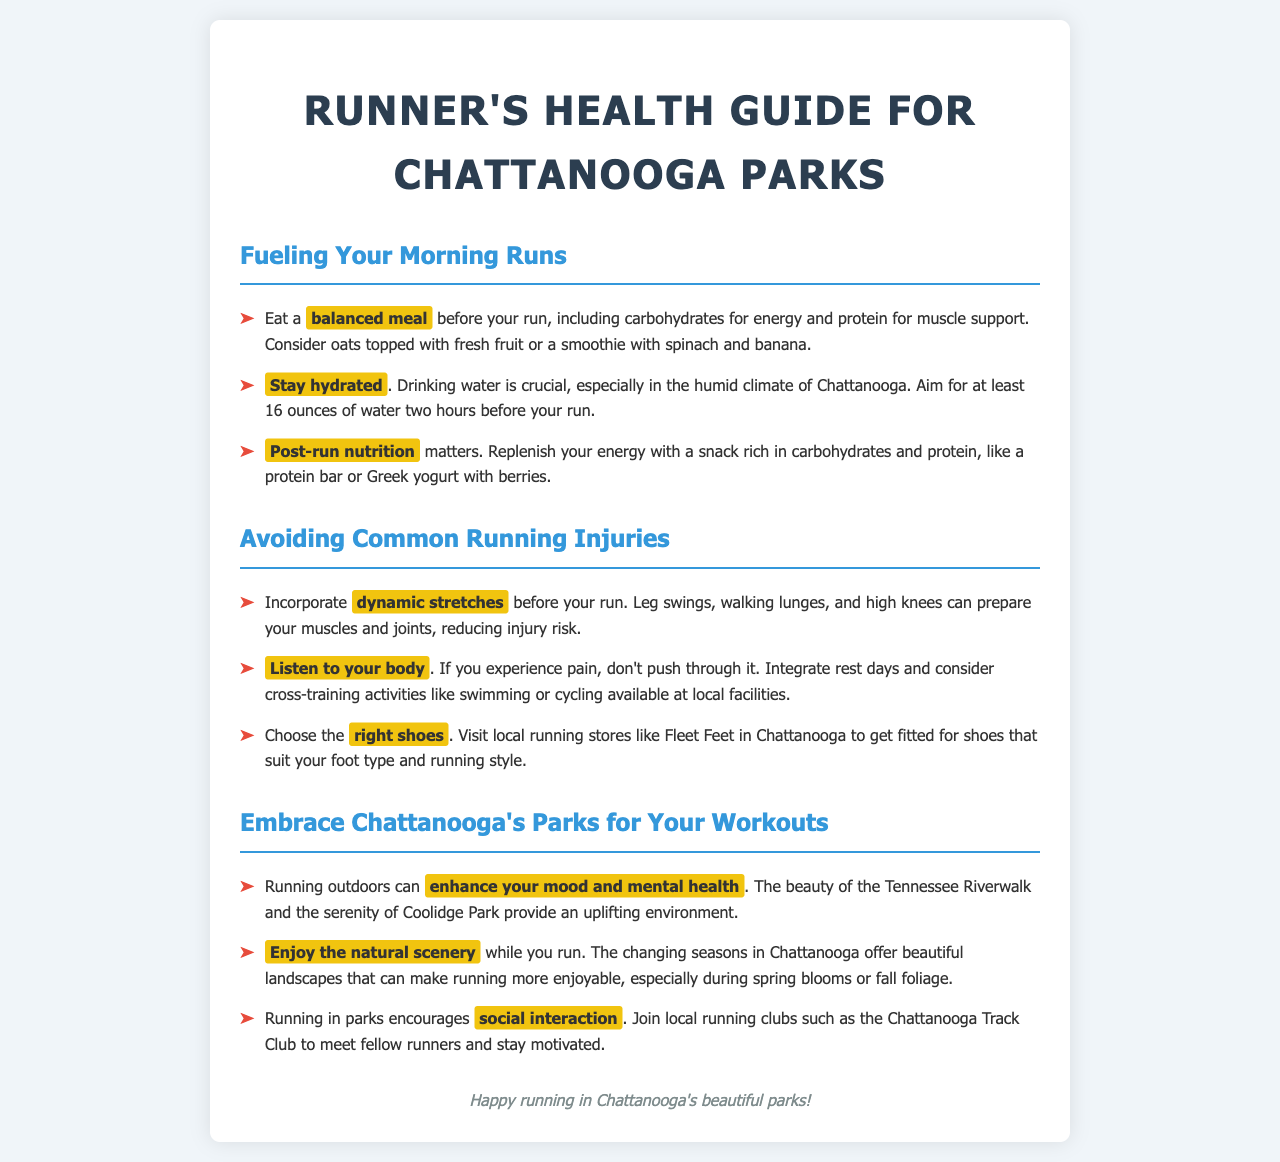What should you eat before your run? The document suggests eating a balanced meal, including carbohydrates for energy and protein for muscle support, like oats topped with fresh fruit or a smoothie with spinach and banana.
Answer: balanced meal How much water should you drink before your run? It states to aim for at least 16 ounces of water two hours before your run, especially due to Chattanooga's humid climate.
Answer: 16 ounces What type of stretches are recommended? The document recommends incorporating dynamic stretches, such as leg swings, walking lunges, and high knees, before your run.
Answer: dynamic stretches What can enhance your mood and mental health while running? Running outdoors can enhance your mood and mental health, as per the benefits highlighted in the document.
Answer: outdoor exercise Which local store is mentioned for getting fitted for running shoes? The document mentions Fleet Feet in Chattanooga as a local running store for shoe fitting.
Answer: Fleet Feet What aspect of outdoor running is emphasized for socializing? The document emphasizes that running in parks encourages social interaction through local running clubs like the Chattanooga Track Club.
Answer: social interaction What should you do if you experience pain while running? It advises to not push through pain and integrate rest days, considering cross-training activities instead.
Answer: Don't push through it What kind of nutrition is advised after running? The document suggests replenishing energy with a snack rich in carbohydrates and protein, like a protein bar or Greek yogurt with berries.
Answer: rich in carbohydrates and protein 